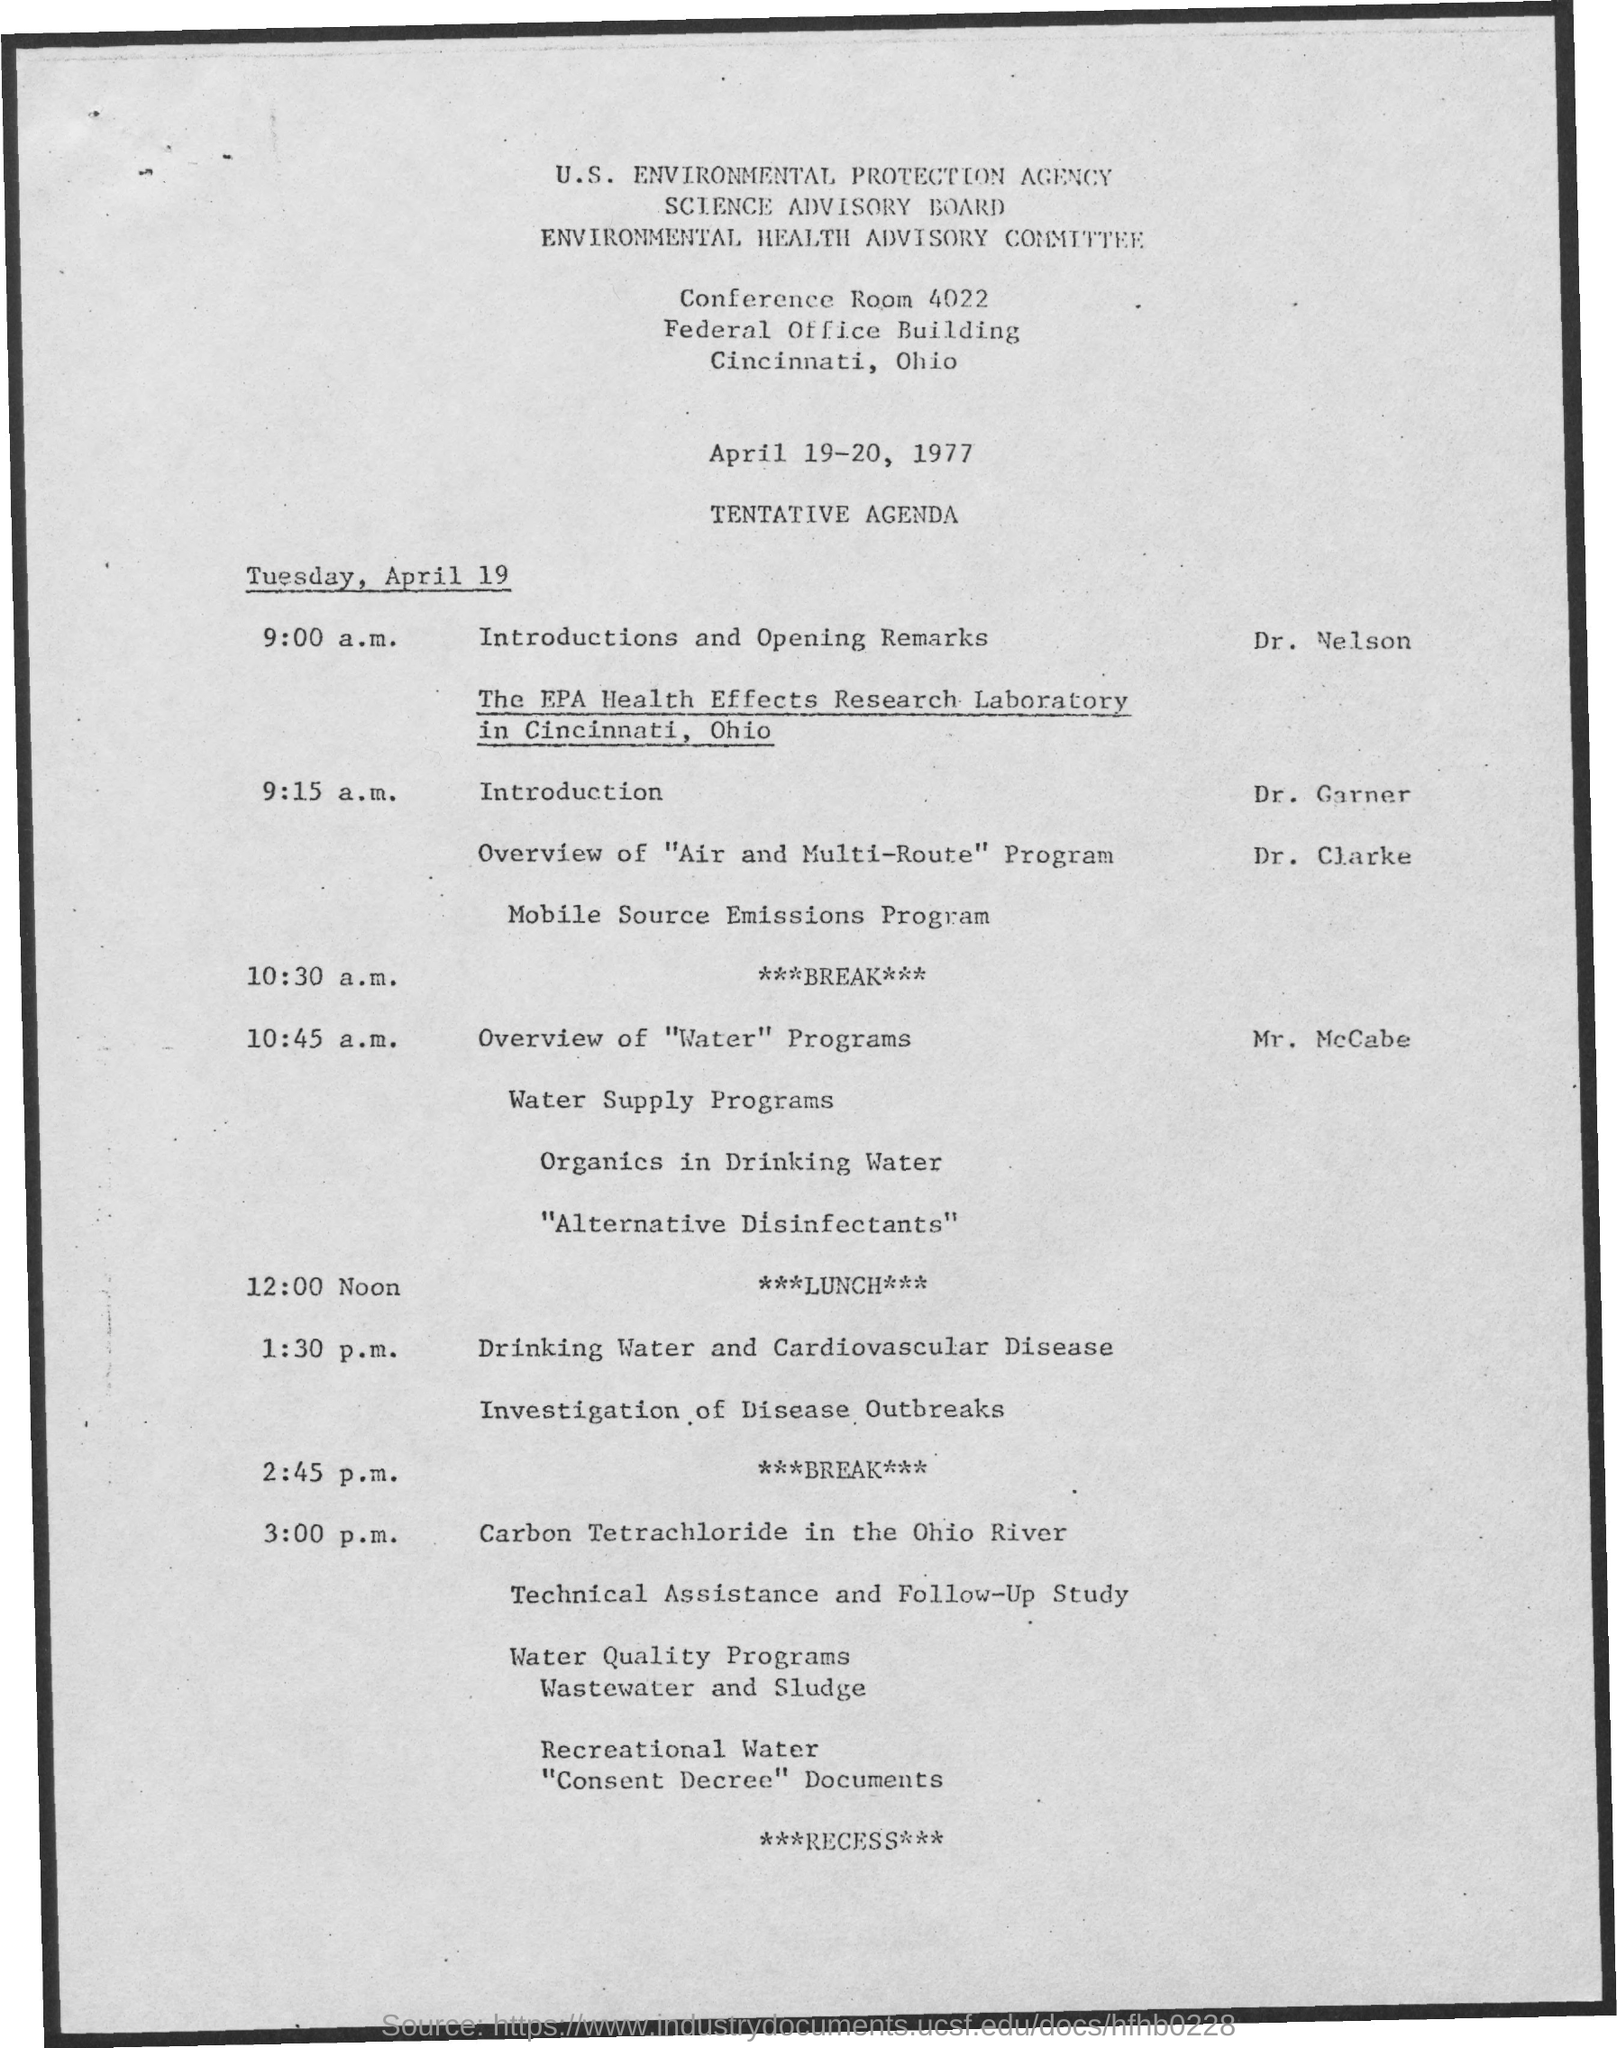What is the name of the agency mentioned ?
Your response must be concise. U.S. environmental protection agency. What is the name of the board mentioned ?
Your response must be concise. Science advisory board. What is the name of the committee mentioned ?
Offer a terse response. ENVIRONMENTAL HEALTH ADVISORY COMMITTEE. What is the conference room no. mentioned ?
Your answer should be very brief. 4022. What are the dates mentioned ?
Make the answer very short. April 19-20, 1977. What is the schedule at the time of 12:00 noon on april 19 ?
Offer a terse response. LUNCH. 